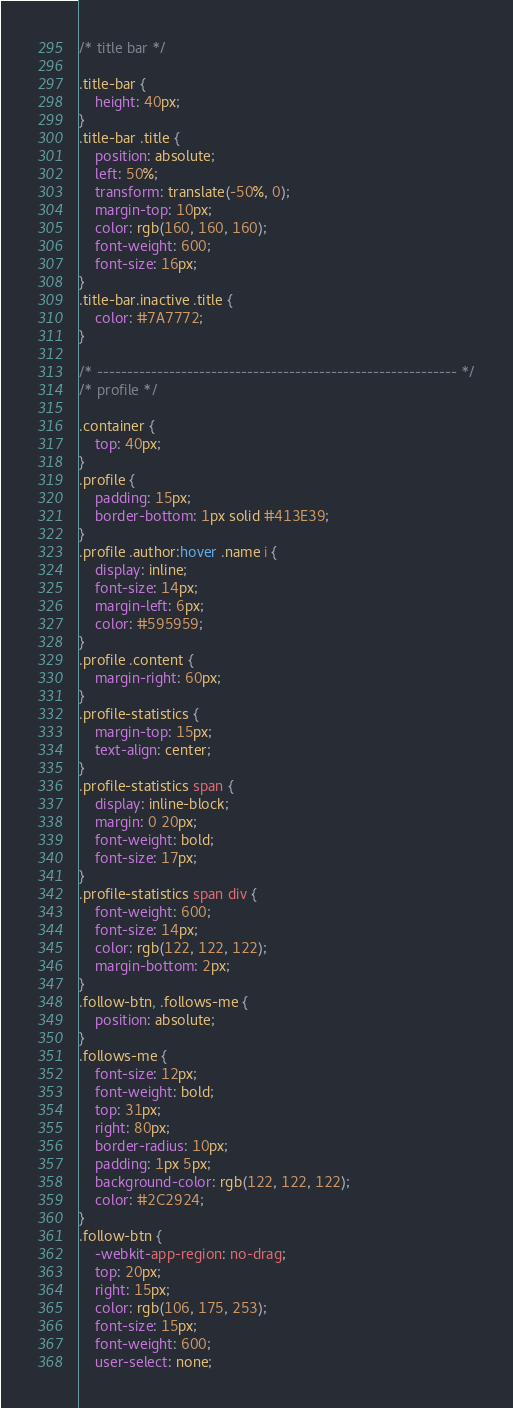Convert code to text. <code><loc_0><loc_0><loc_500><loc_500><_CSS_>/* title bar */

.title-bar {
    height: 40px;
}
.title-bar .title {
    position: absolute;
    left: 50%;
    transform: translate(-50%, 0);
    margin-top: 10px;
    color: rgb(160, 160, 160);
    font-weight: 600;
    font-size: 16px;
}
.title-bar.inactive .title {
    color: #7A7772;
}

/* ------------------------------------------------------------ */
/* profile */

.container {
    top: 40px;
}
.profile {
    padding: 15px;
    border-bottom: 1px solid #413E39;
}
.profile .author:hover .name i {
    display: inline;
    font-size: 14px;
    margin-left: 6px;
    color: #595959;
}
.profile .content {
    margin-right: 60px;
}
.profile-statistics {
    margin-top: 15px;
    text-align: center;
}
.profile-statistics span {
    display: inline-block;
    margin: 0 20px;
    font-weight: bold;
    font-size: 17px;
}
.profile-statistics span div {
    font-weight: 600;
    font-size: 14px;
    color: rgb(122, 122, 122);
    margin-bottom: 2px;
}
.follow-btn, .follows-me {
    position: absolute;
}
.follows-me {
    font-size: 12px;
    font-weight: bold;
    top: 31px;
    right: 80px;
    border-radius: 10px;
    padding: 1px 5px;
    background-color: rgb(122, 122, 122);
    color: #2C2924;
}
.follow-btn {
    -webkit-app-region: no-drag;
    top: 20px;
    right: 15px;
    color: rgb(106, 175, 253);
    font-size: 15px;
    font-weight: 600;
    user-select: none;</code> 